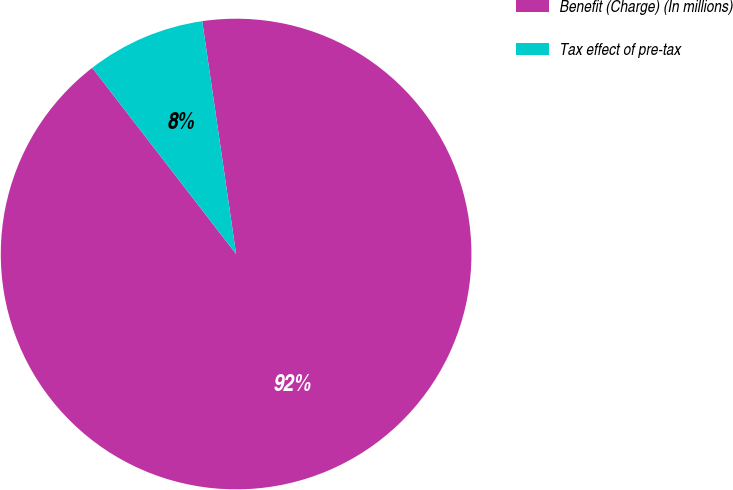Convert chart to OTSL. <chart><loc_0><loc_0><loc_500><loc_500><pie_chart><fcel>Benefit (Charge) (In millions)<fcel>Tax effect of pre-tax<nl><fcel>91.83%<fcel>8.17%<nl></chart> 